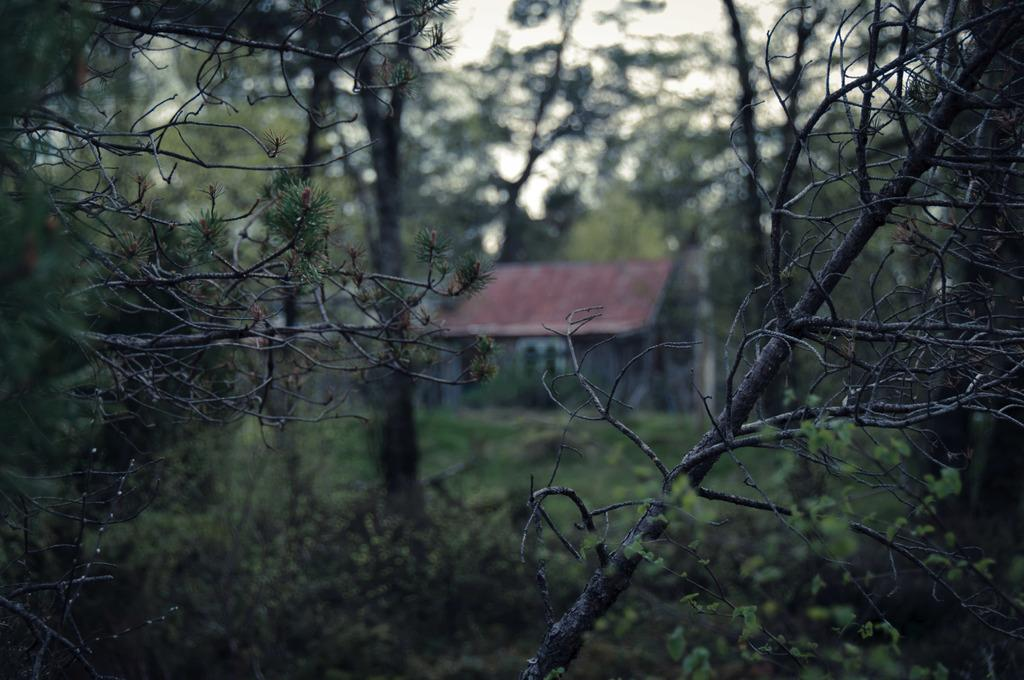What type of structure is visible in the image? There is a house in the image. What type of vegetation is present in the image? There is grass and trees in the image. What is the color of the sky in the image? The sky is white in the image. How many loaves of bread can be seen on the roof of the house in the image? There is no bread visible on the roof of the house in the image. 